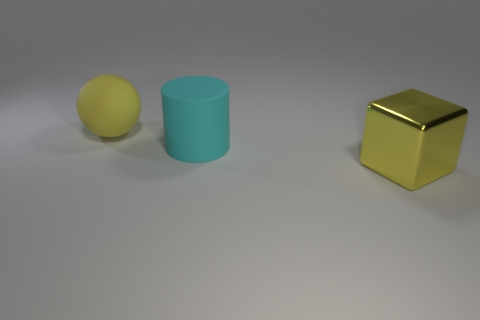How many big things are either yellow rubber objects or matte cylinders?
Keep it short and to the point. 2. Does the yellow thing that is behind the large yellow metal thing have the same size as the yellow thing in front of the yellow matte sphere?
Offer a terse response. Yes. Are there more large yellow rubber balls that are in front of the rubber ball than large matte things that are behind the shiny object?
Offer a terse response. No. There is a big object that is both on the right side of the ball and on the left side of the shiny object; what is its material?
Provide a succinct answer. Rubber. The shiny block is what size?
Provide a short and direct response. Large. The metal block that is right of the yellow thing on the left side of the big yellow metal thing is what color?
Provide a short and direct response. Yellow. How many big objects are on the left side of the large block and in front of the big yellow ball?
Make the answer very short. 1. Is the number of metal blocks greater than the number of large purple balls?
Provide a succinct answer. Yes. What is the cyan cylinder made of?
Give a very brief answer. Rubber. What number of big spheres are behind the big yellow thing on the left side of the yellow block?
Ensure brevity in your answer.  0. 